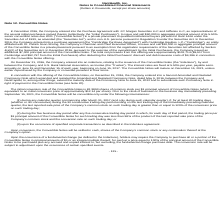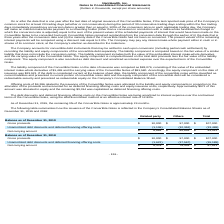According to Nanthealth's financial document, What is the value of the related party gross proceeds as of December 31, 2019? According to the financial document, $10,000 (in thousands). The relevant text states: "man and Chief Executive Officer, to issue and sell $10,000 in aggregate principal amount of the Convertible Notes in a private placement pursuant to an exempti..." Also, What is the value of other gross proceeds as of December 31, 2019? According to the financial document, $97,000 (in thousands). The relevant text states: "Gross proceeds $ 10,000 $ 97,000 $ 107,000..." Also, What is the value of the company's total gross proceeds as of December 31, 2019? According to the financial document, $107,000 (in thousands). The relevant text states: "Gross proceeds $ 10,000 $ 97,000 $ 107,000..." Also, can you calculate: What is the value of the company's related party gross proceeds as a percentage of its total gross proceeds in 2019? Based on the calculation: 10,000/107,000 , the result is 9.35 (percentage). This is based on the information: "n and Chief Executive Officer, to issue and sell $10,000 in aggregate principal amount of the Convertible Notes in a private placement pursuant to an exempt Gross proceeds $ 10,000 $ 97,000 $ 107,000..." The key data points involved are: 10,000, 107,000. Also, can you calculate: What is the average net carrying amount of the company's related party transaction in 2018 and 2019? To answer this question, I need to perform calculations using the financial data. The calculation is: (8,864 + 8,378)/2 , which equals 8621 (in thousands). This is based on the information: "Net carrying amount $ 8,378 $ 79,433 $ 87,811 Net carrying amount $ 8,864 $ 84,648 $ 93,512..." The key data points involved are: 8,378, 8,864. Also, can you calculate: What is the percentage change in the company's net carrying amount of related party transaction between 2018 and 2019? To answer this question, I need to perform calculations using the financial data. The calculation is: (8,864 - 8,378)/8,378 , which equals 5.8 (percentage). This is based on the information: "Net carrying amount $ 8,378 $ 79,433 $ 87,811 Net carrying amount $ 8,864 $ 84,648 $ 93,512..." The key data points involved are: 8,378, 8,864. 